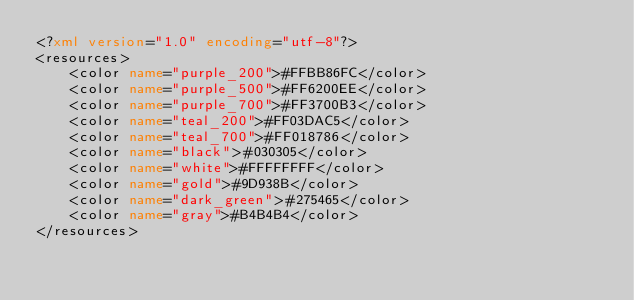Convert code to text. <code><loc_0><loc_0><loc_500><loc_500><_XML_><?xml version="1.0" encoding="utf-8"?>
<resources>
    <color name="purple_200">#FFBB86FC</color>
    <color name="purple_500">#FF6200EE</color>
    <color name="purple_700">#FF3700B3</color>
    <color name="teal_200">#FF03DAC5</color>
    <color name="teal_700">#FF018786</color>
    <color name="black">#030305</color>
    <color name="white">#FFFFFFFF</color>
    <color name="gold">#9D938B</color>
    <color name="dark_green">#275465</color>
    <color name="gray">#B4B4B4</color>
</resources></code> 